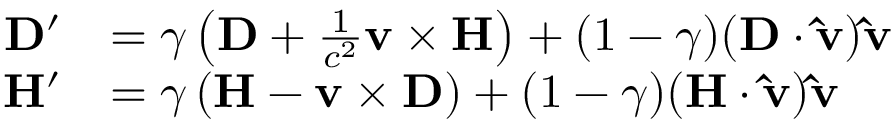<formula> <loc_0><loc_0><loc_500><loc_500>{ \begin{array} { r l } { D ^ { \prime } } & { = \gamma \left ( D + { \frac { 1 } { c ^ { 2 } } } v \times H \right ) + ( 1 - \gamma ) ( D \cdot \hat { v } ) \hat { v } } \\ { H ^ { \prime } } & { = \gamma \left ( H - v \times D \right ) + ( 1 - \gamma ) ( H \cdot \hat { v } ) \hat { v } } \end{array} }</formula> 